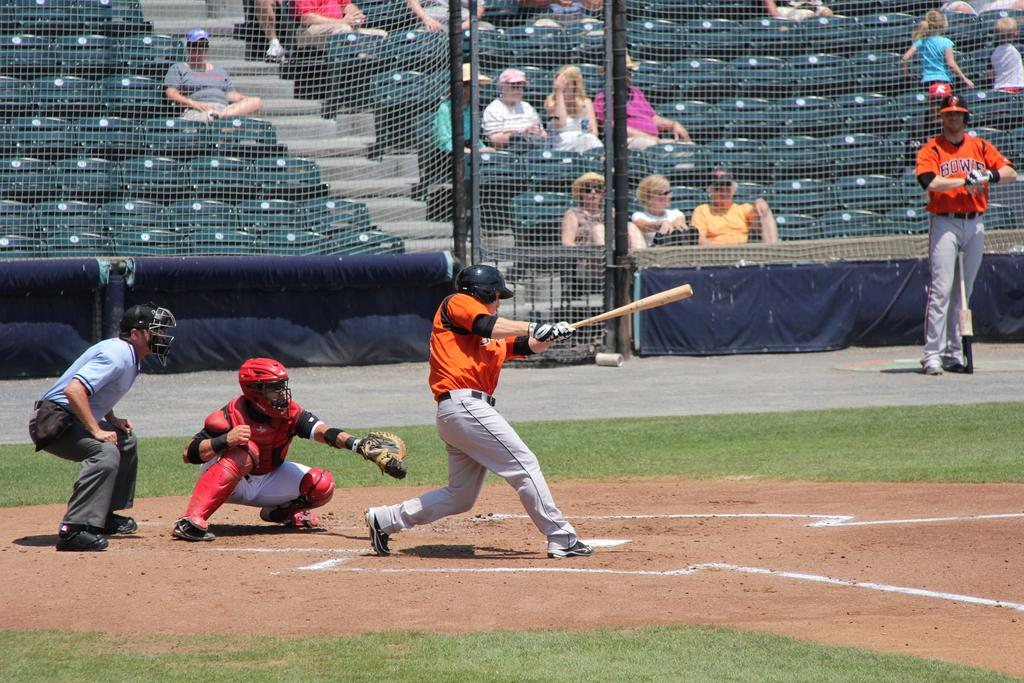<image>
Provide a brief description of the given image. A player for the baseball team Bowie in an orange and gray uniform swings at the ball. 